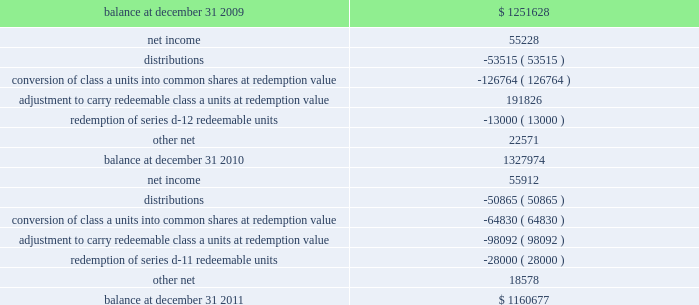Vornado realty trust notes to consolidated financial statements ( continued ) 10 .
Redeemable noncontrolling interests - continued redeemable noncontrolling interests on our consolidated balance sheets are recorded at the greater of their carrying amount or redemption value at the end of each reporting period .
Changes in the value from period to period are charged to 201cadditional capital 201d in our consolidated statements of changes in equity .
Below is a table summarizing the activity of redeemable noncontrolling interests .
( amounts in thousands ) .
Redeemable noncontrolling interests exclude our series g convertible preferred units and series d-13 cumulative redeemable preferred units , as they are accounted for as liabilities in accordance with asc 480 , distinguishing liabilities and equity , because of their possible settlement by issuing a variable number of vornado common shares .
Accordingly , the fair value of these units is included as a component of 201cother liabilities 201d on our consolidated balance sheets and aggregated $ 54865000 and $ 55097000 as of december 31 , 2011 and 2010 , respectively. .
What was the percentage change in the redeemable noncontrolling interests from 2009 to 2010? 
Computations: ((1327974 - 1251628) / 1251628)
Answer: 0.061. 